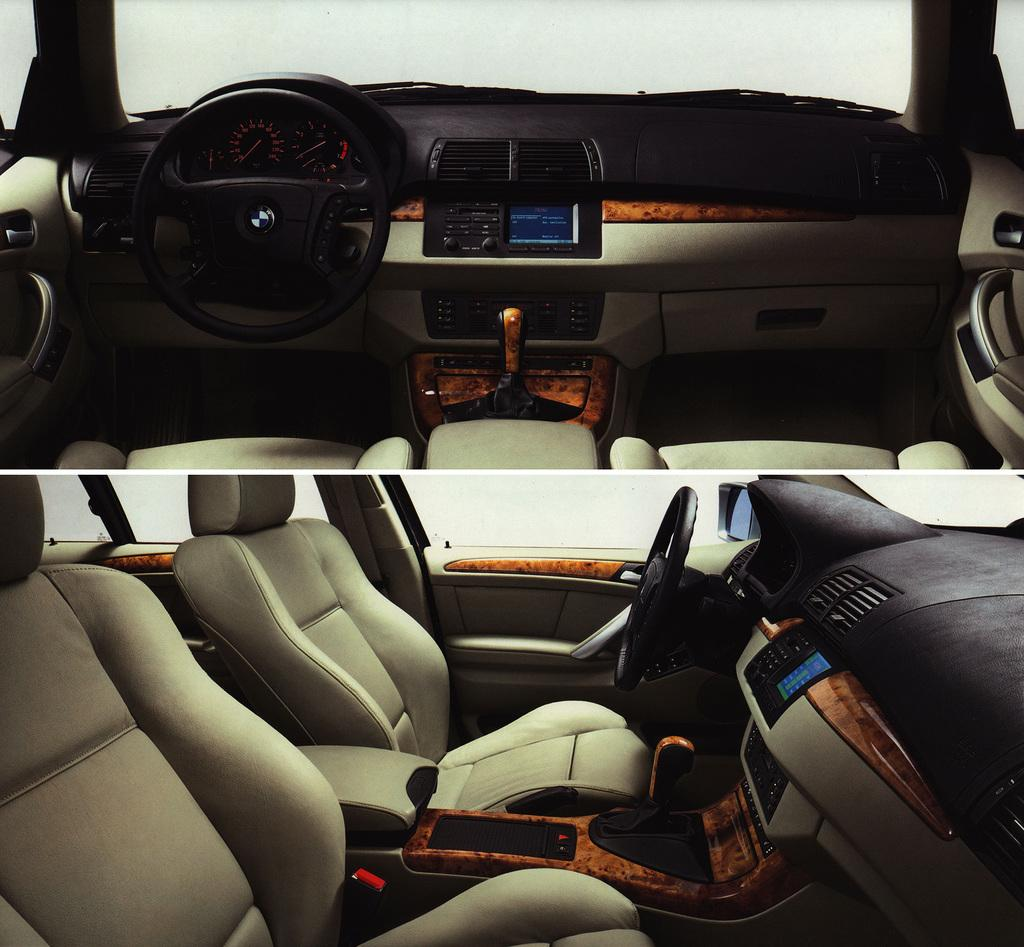What type of artwork is the image? The image is a collage. What can be seen in the top part of the collage? There is a vehicle and a steering wheel in the top part of the image. What is present in the bottom part of the collage? There are seats, windows, and a mirror in the bottom part of the image. What type of beef is being cooked in the image? There is no beef or cooking activity present in the image. 